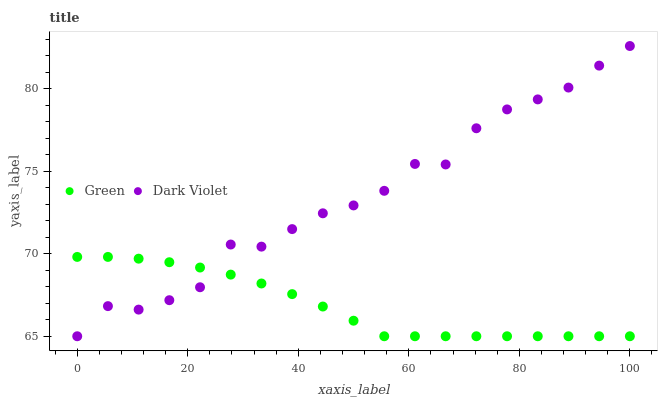Does Green have the minimum area under the curve?
Answer yes or no. Yes. Does Dark Violet have the maximum area under the curve?
Answer yes or no. Yes. Does Dark Violet have the minimum area under the curve?
Answer yes or no. No. Is Green the smoothest?
Answer yes or no. Yes. Is Dark Violet the roughest?
Answer yes or no. Yes. Is Dark Violet the smoothest?
Answer yes or no. No. Does Green have the lowest value?
Answer yes or no. Yes. Does Dark Violet have the highest value?
Answer yes or no. Yes. Does Dark Violet intersect Green?
Answer yes or no. Yes. Is Dark Violet less than Green?
Answer yes or no. No. Is Dark Violet greater than Green?
Answer yes or no. No. 